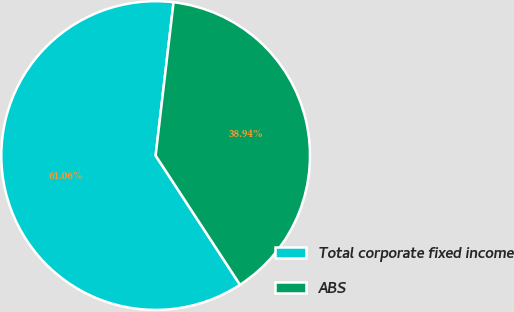<chart> <loc_0><loc_0><loc_500><loc_500><pie_chart><fcel>Total corporate fixed income<fcel>ABS<nl><fcel>61.06%<fcel>38.94%<nl></chart> 